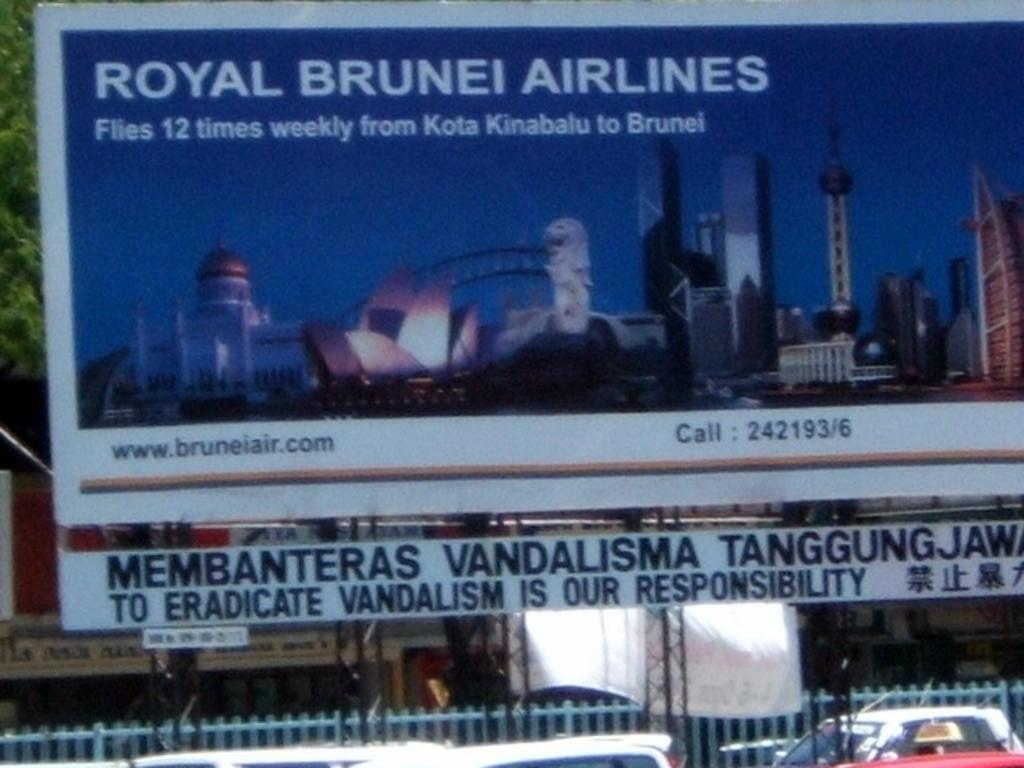<image>
Summarize the visual content of the image. A large billboard of a city that says Royal Brunei Airlines. 